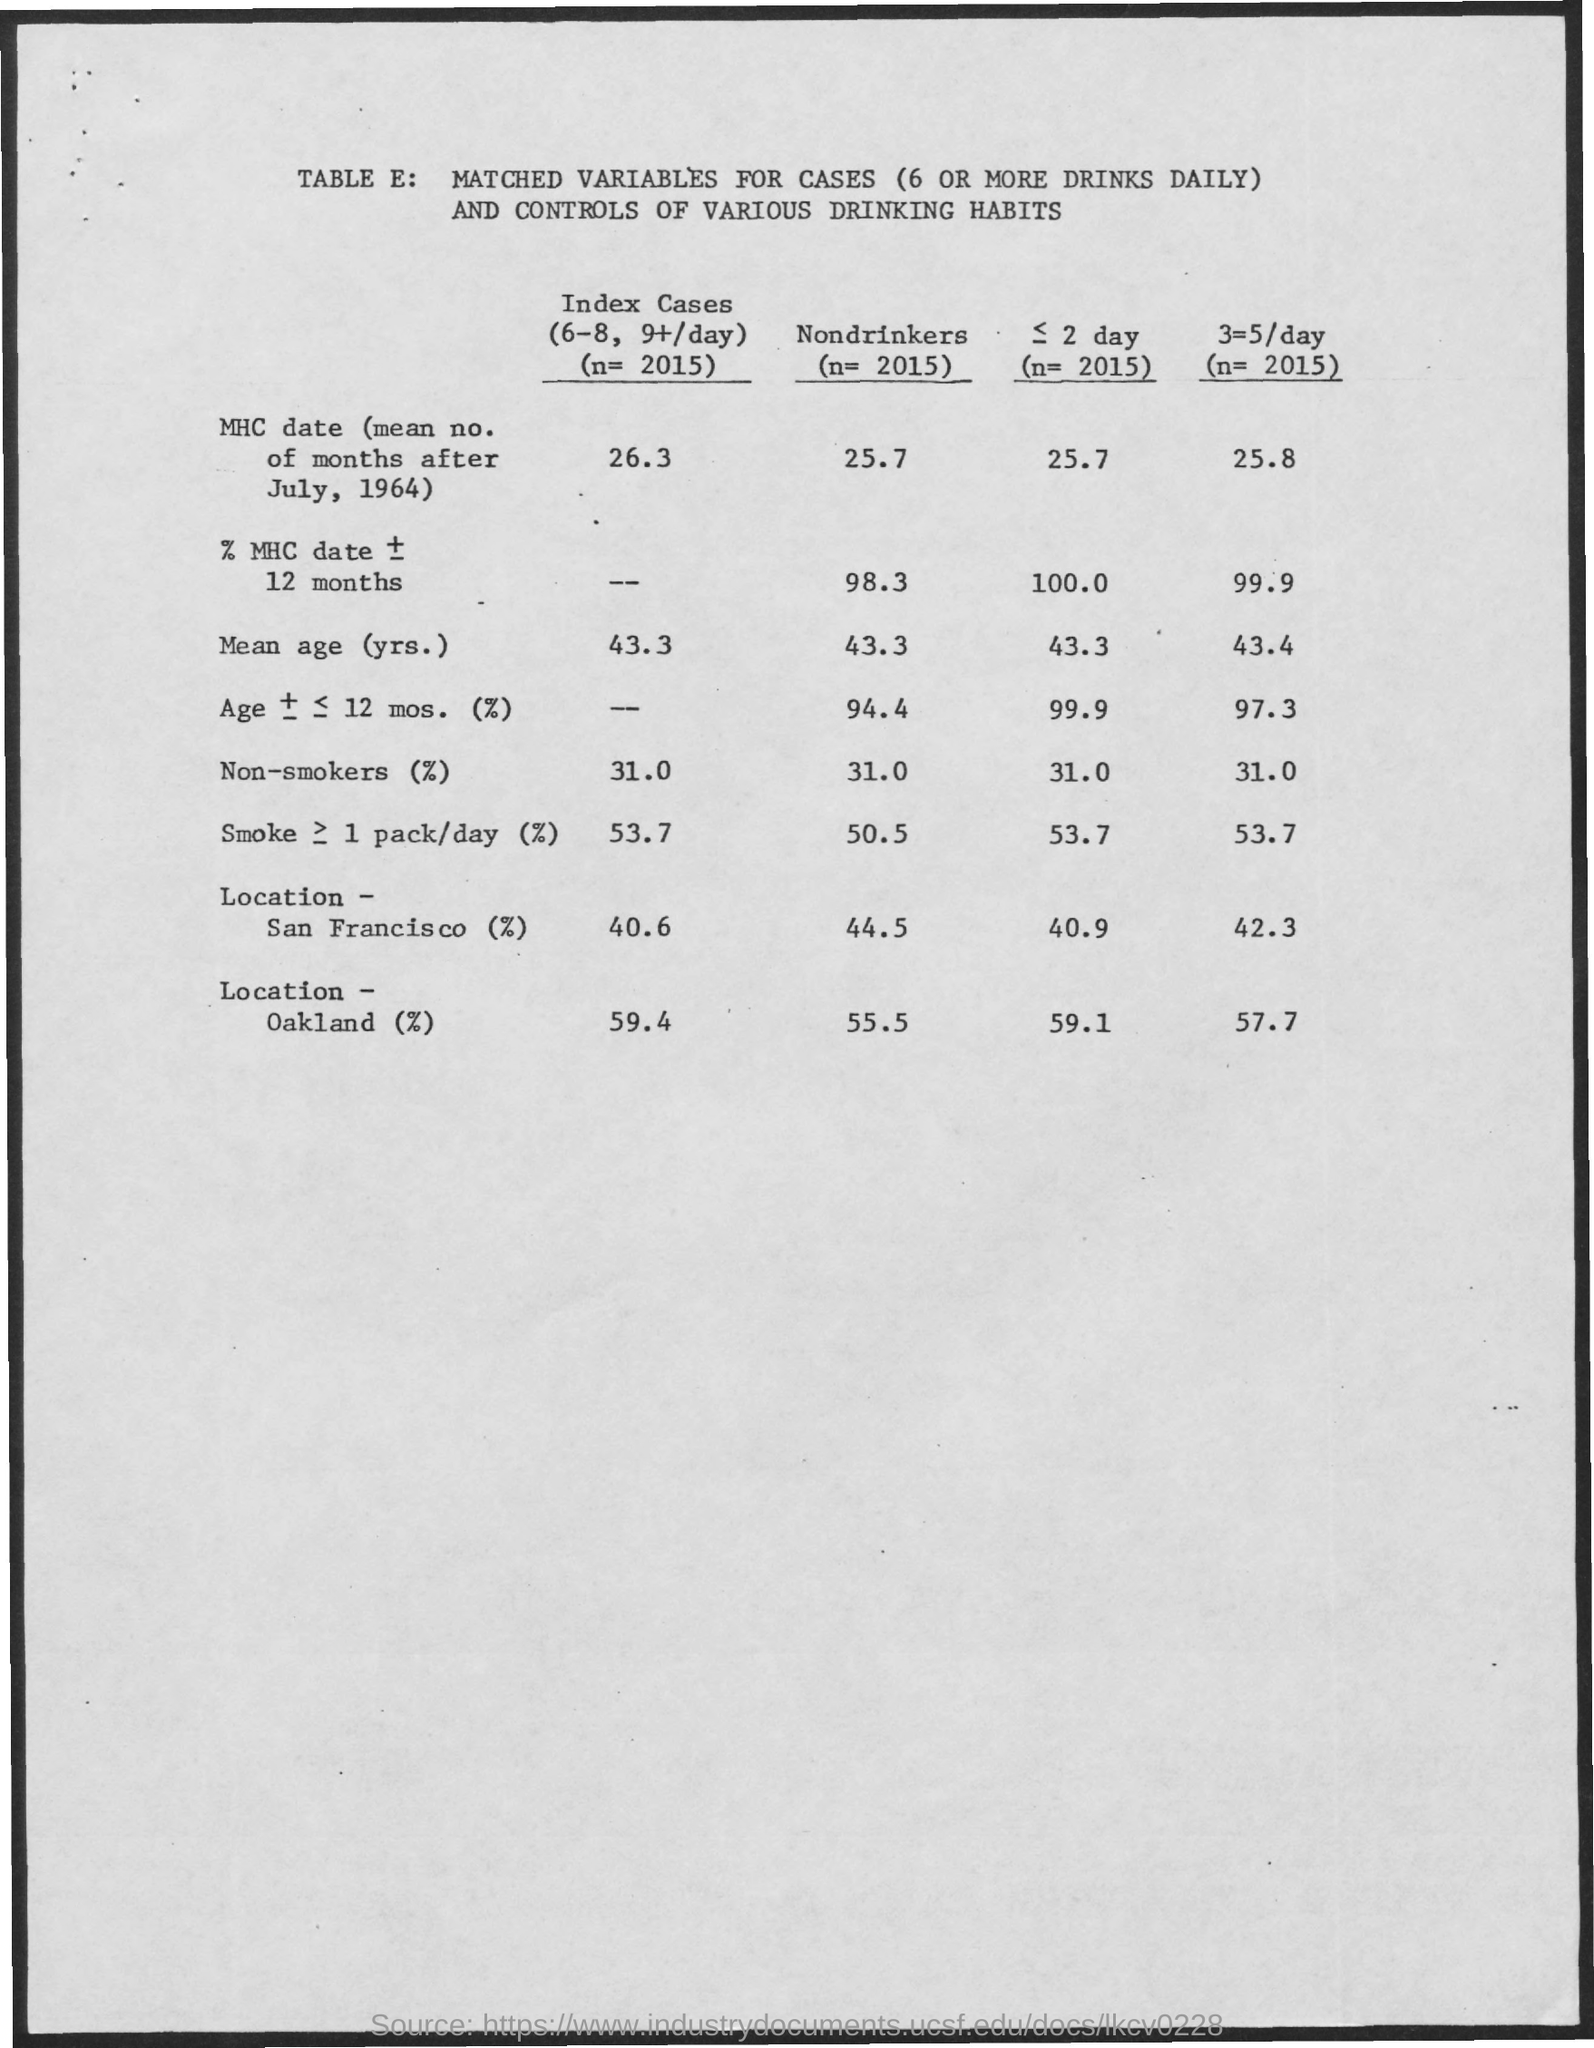What is the value of Nondrinkers (n= 2015) for MHC date (mean no. of months after July, 1964)?
Provide a short and direct response. 25.7. What is the value of Nondrinkers (n= 2015) for Mean age (yrs.)?
Give a very brief answer. 43.3. 